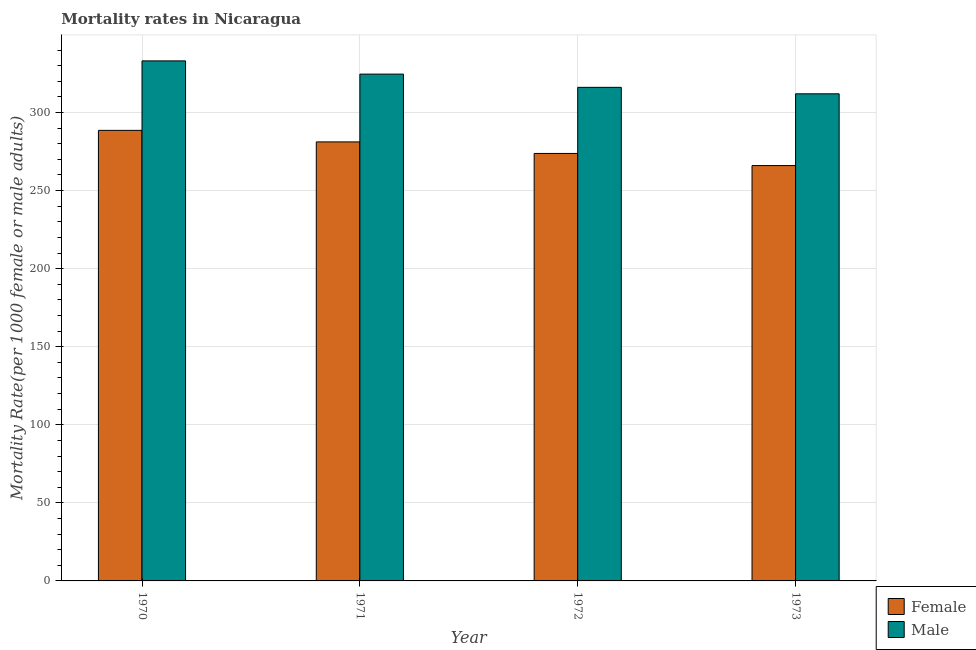How many different coloured bars are there?
Your answer should be very brief. 2. Are the number of bars per tick equal to the number of legend labels?
Offer a terse response. Yes. How many bars are there on the 3rd tick from the left?
Your response must be concise. 2. How many bars are there on the 2nd tick from the right?
Your response must be concise. 2. In how many cases, is the number of bars for a given year not equal to the number of legend labels?
Your response must be concise. 0. What is the male mortality rate in 1973?
Provide a succinct answer. 311.95. Across all years, what is the maximum male mortality rate?
Provide a short and direct response. 333.05. Across all years, what is the minimum female mortality rate?
Provide a short and direct response. 266. In which year was the male mortality rate maximum?
Your answer should be very brief. 1970. In which year was the female mortality rate minimum?
Provide a short and direct response. 1973. What is the total male mortality rate in the graph?
Ensure brevity in your answer.  1285.67. What is the difference between the male mortality rate in 1970 and that in 1971?
Your answer should be very brief. 8.48. What is the difference between the male mortality rate in 1972 and the female mortality rate in 1973?
Your answer should be very brief. 4.14. What is the average male mortality rate per year?
Provide a succinct answer. 321.42. What is the ratio of the male mortality rate in 1972 to that in 1973?
Make the answer very short. 1.01. What is the difference between the highest and the second highest male mortality rate?
Keep it short and to the point. 8.48. What is the difference between the highest and the lowest female mortality rate?
Offer a very short reply. 22.55. Is the sum of the female mortality rate in 1970 and 1971 greater than the maximum male mortality rate across all years?
Offer a very short reply. Yes. What does the 2nd bar from the left in 1970 represents?
Ensure brevity in your answer.  Male. What does the 1st bar from the right in 1973 represents?
Offer a very short reply. Male. Are all the bars in the graph horizontal?
Provide a succinct answer. No. What is the difference between two consecutive major ticks on the Y-axis?
Offer a very short reply. 50. Are the values on the major ticks of Y-axis written in scientific E-notation?
Offer a very short reply. No. Where does the legend appear in the graph?
Provide a succinct answer. Bottom right. How many legend labels are there?
Offer a very short reply. 2. How are the legend labels stacked?
Your answer should be compact. Vertical. What is the title of the graph?
Keep it short and to the point. Mortality rates in Nicaragua. What is the label or title of the Y-axis?
Offer a very short reply. Mortality Rate(per 1000 female or male adults). What is the Mortality Rate(per 1000 female or male adults) of Female in 1970?
Offer a very short reply. 288.55. What is the Mortality Rate(per 1000 female or male adults) of Male in 1970?
Provide a succinct answer. 333.05. What is the Mortality Rate(per 1000 female or male adults) in Female in 1971?
Provide a succinct answer. 281.16. What is the Mortality Rate(per 1000 female or male adults) of Male in 1971?
Your answer should be compact. 324.57. What is the Mortality Rate(per 1000 female or male adults) of Female in 1972?
Make the answer very short. 273.76. What is the Mortality Rate(per 1000 female or male adults) of Male in 1972?
Make the answer very short. 316.09. What is the Mortality Rate(per 1000 female or male adults) of Female in 1973?
Provide a short and direct response. 266. What is the Mortality Rate(per 1000 female or male adults) in Male in 1973?
Offer a terse response. 311.95. Across all years, what is the maximum Mortality Rate(per 1000 female or male adults) of Female?
Offer a terse response. 288.55. Across all years, what is the maximum Mortality Rate(per 1000 female or male adults) of Male?
Give a very brief answer. 333.05. Across all years, what is the minimum Mortality Rate(per 1000 female or male adults) of Female?
Keep it short and to the point. 266. Across all years, what is the minimum Mortality Rate(per 1000 female or male adults) in Male?
Your answer should be very brief. 311.95. What is the total Mortality Rate(per 1000 female or male adults) in Female in the graph?
Your response must be concise. 1109.47. What is the total Mortality Rate(per 1000 female or male adults) of Male in the graph?
Provide a succinct answer. 1285.67. What is the difference between the Mortality Rate(per 1000 female or male adults) of Female in 1970 and that in 1971?
Ensure brevity in your answer.  7.39. What is the difference between the Mortality Rate(per 1000 female or male adults) in Male in 1970 and that in 1971?
Give a very brief answer. 8.48. What is the difference between the Mortality Rate(per 1000 female or male adults) of Female in 1970 and that in 1972?
Your response must be concise. 14.79. What is the difference between the Mortality Rate(per 1000 female or male adults) of Male in 1970 and that in 1972?
Keep it short and to the point. 16.96. What is the difference between the Mortality Rate(per 1000 female or male adults) in Female in 1970 and that in 1973?
Offer a terse response. 22.55. What is the difference between the Mortality Rate(per 1000 female or male adults) in Male in 1970 and that in 1973?
Ensure brevity in your answer.  21.1. What is the difference between the Mortality Rate(per 1000 female or male adults) in Female in 1971 and that in 1972?
Your answer should be compact. 7.39. What is the difference between the Mortality Rate(per 1000 female or male adults) of Male in 1971 and that in 1972?
Your response must be concise. 8.48. What is the difference between the Mortality Rate(per 1000 female or male adults) in Female in 1971 and that in 1973?
Keep it short and to the point. 15.15. What is the difference between the Mortality Rate(per 1000 female or male adults) in Male in 1971 and that in 1973?
Give a very brief answer. 12.62. What is the difference between the Mortality Rate(per 1000 female or male adults) of Female in 1972 and that in 1973?
Your answer should be compact. 7.76. What is the difference between the Mortality Rate(per 1000 female or male adults) in Male in 1972 and that in 1973?
Keep it short and to the point. 4.14. What is the difference between the Mortality Rate(per 1000 female or male adults) of Female in 1970 and the Mortality Rate(per 1000 female or male adults) of Male in 1971?
Provide a succinct answer. -36.02. What is the difference between the Mortality Rate(per 1000 female or male adults) in Female in 1970 and the Mortality Rate(per 1000 female or male adults) in Male in 1972?
Keep it short and to the point. -27.54. What is the difference between the Mortality Rate(per 1000 female or male adults) in Female in 1970 and the Mortality Rate(per 1000 female or male adults) in Male in 1973?
Keep it short and to the point. -23.4. What is the difference between the Mortality Rate(per 1000 female or male adults) in Female in 1971 and the Mortality Rate(per 1000 female or male adults) in Male in 1972?
Provide a succinct answer. -34.94. What is the difference between the Mortality Rate(per 1000 female or male adults) of Female in 1971 and the Mortality Rate(per 1000 female or male adults) of Male in 1973?
Ensure brevity in your answer.  -30.8. What is the difference between the Mortality Rate(per 1000 female or male adults) in Female in 1972 and the Mortality Rate(per 1000 female or male adults) in Male in 1973?
Your answer should be compact. -38.19. What is the average Mortality Rate(per 1000 female or male adults) in Female per year?
Your answer should be compact. 277.37. What is the average Mortality Rate(per 1000 female or male adults) of Male per year?
Provide a short and direct response. 321.42. In the year 1970, what is the difference between the Mortality Rate(per 1000 female or male adults) in Female and Mortality Rate(per 1000 female or male adults) in Male?
Ensure brevity in your answer.  -44.5. In the year 1971, what is the difference between the Mortality Rate(per 1000 female or male adults) of Female and Mortality Rate(per 1000 female or male adults) of Male?
Give a very brief answer. -43.41. In the year 1972, what is the difference between the Mortality Rate(per 1000 female or male adults) in Female and Mortality Rate(per 1000 female or male adults) in Male?
Ensure brevity in your answer.  -42.33. In the year 1973, what is the difference between the Mortality Rate(per 1000 female or male adults) in Female and Mortality Rate(per 1000 female or male adults) in Male?
Ensure brevity in your answer.  -45.95. What is the ratio of the Mortality Rate(per 1000 female or male adults) of Female in 1970 to that in 1971?
Offer a terse response. 1.03. What is the ratio of the Mortality Rate(per 1000 female or male adults) of Male in 1970 to that in 1971?
Keep it short and to the point. 1.03. What is the ratio of the Mortality Rate(per 1000 female or male adults) in Female in 1970 to that in 1972?
Make the answer very short. 1.05. What is the ratio of the Mortality Rate(per 1000 female or male adults) of Male in 1970 to that in 1972?
Give a very brief answer. 1.05. What is the ratio of the Mortality Rate(per 1000 female or male adults) in Female in 1970 to that in 1973?
Give a very brief answer. 1.08. What is the ratio of the Mortality Rate(per 1000 female or male adults) in Male in 1970 to that in 1973?
Offer a terse response. 1.07. What is the ratio of the Mortality Rate(per 1000 female or male adults) in Female in 1971 to that in 1972?
Your response must be concise. 1.03. What is the ratio of the Mortality Rate(per 1000 female or male adults) in Male in 1971 to that in 1972?
Offer a terse response. 1.03. What is the ratio of the Mortality Rate(per 1000 female or male adults) in Female in 1971 to that in 1973?
Give a very brief answer. 1.06. What is the ratio of the Mortality Rate(per 1000 female or male adults) of Male in 1971 to that in 1973?
Provide a succinct answer. 1.04. What is the ratio of the Mortality Rate(per 1000 female or male adults) of Female in 1972 to that in 1973?
Provide a succinct answer. 1.03. What is the ratio of the Mortality Rate(per 1000 female or male adults) in Male in 1972 to that in 1973?
Your answer should be very brief. 1.01. What is the difference between the highest and the second highest Mortality Rate(per 1000 female or male adults) in Female?
Provide a succinct answer. 7.39. What is the difference between the highest and the second highest Mortality Rate(per 1000 female or male adults) in Male?
Offer a very short reply. 8.48. What is the difference between the highest and the lowest Mortality Rate(per 1000 female or male adults) in Female?
Your answer should be compact. 22.55. What is the difference between the highest and the lowest Mortality Rate(per 1000 female or male adults) of Male?
Your response must be concise. 21.1. 